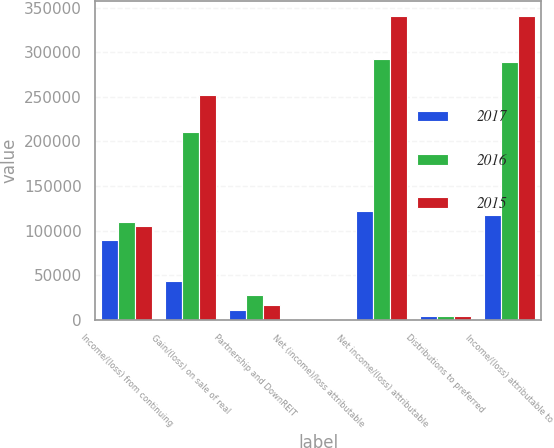Convert chart. <chart><loc_0><loc_0><loc_500><loc_500><stacked_bar_chart><ecel><fcel>Income/(loss) from continuing<fcel>Gain/(loss) on sale of real<fcel>Partnership and DownREIT<fcel>Net (income)/loss attributable<fcel>Net income/(loss) attributable<fcel>Distributions to preferred<fcel>Income/(loss) attributable to<nl><fcel>2017<fcel>89251<fcel>43404<fcel>10933<fcel>164<fcel>121558<fcel>3708<fcel>117850<nl><fcel>2016<fcel>109529<fcel>210851<fcel>27282<fcel>380<fcel>292718<fcel>3717<fcel>289001<nl><fcel>2015<fcel>105482<fcel>251677<fcel>16773<fcel>3<fcel>340383<fcel>3722<fcel>340383<nl></chart> 